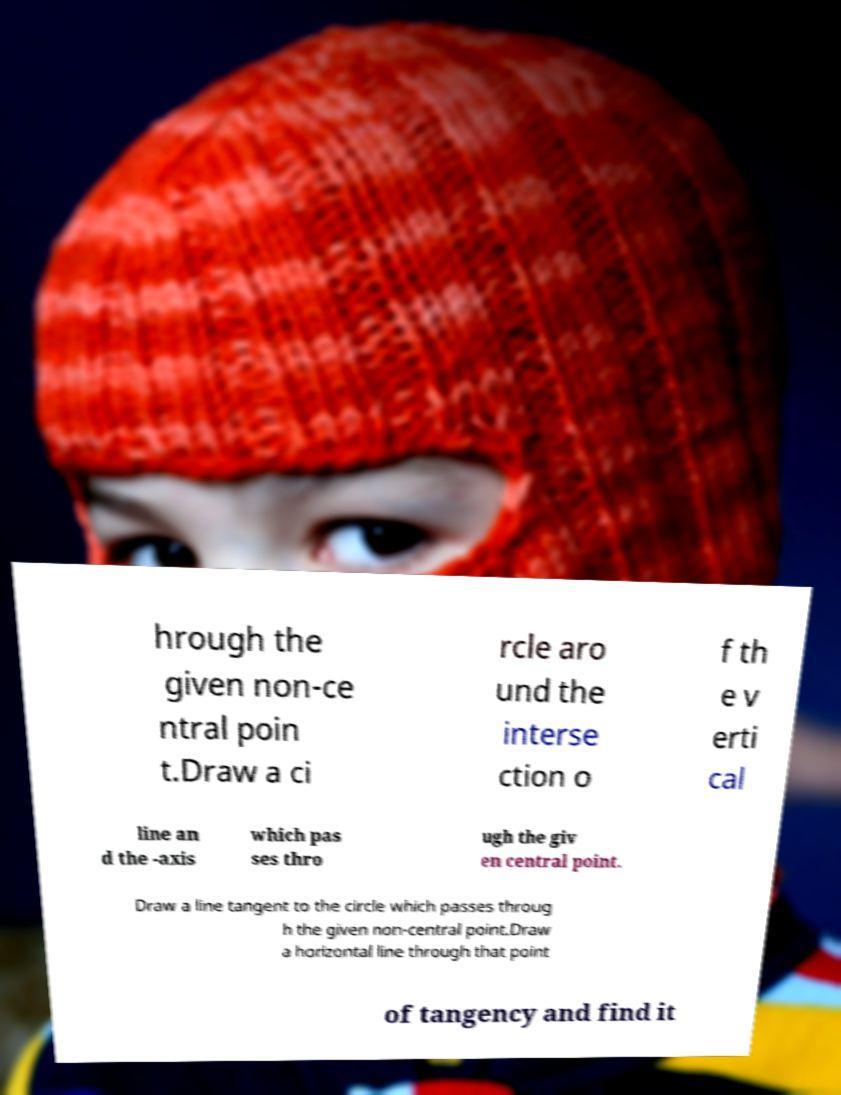Can you read and provide the text displayed in the image?This photo seems to have some interesting text. Can you extract and type it out for me? hrough the given non-ce ntral poin t.Draw a ci rcle aro und the interse ction o f th e v erti cal line an d the -axis which pas ses thro ugh the giv en central point. Draw a line tangent to the circle which passes throug h the given non-central point.Draw a horizontal line through that point of tangency and find it 